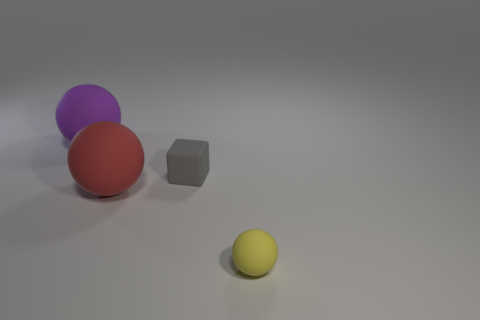Subtract all yellow rubber balls. How many balls are left? 2 Subtract all purple spheres. How many spheres are left? 2 Subtract all spheres. How many objects are left? 1 Subtract 2 spheres. How many spheres are left? 1 Subtract all green spheres. Subtract all brown cylinders. How many spheres are left? 3 Subtract all gray cubes. How many red spheres are left? 1 Subtract all tiny red spheres. Subtract all small gray matte cubes. How many objects are left? 3 Add 2 big rubber objects. How many big rubber objects are left? 4 Add 4 large red spheres. How many large red spheres exist? 5 Add 1 purple rubber objects. How many objects exist? 5 